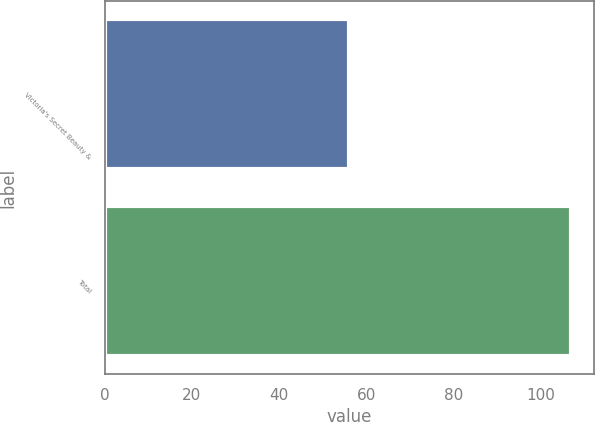Convert chart. <chart><loc_0><loc_0><loc_500><loc_500><bar_chart><fcel>Victoria's Secret Beauty &<fcel>Total<nl><fcel>56<fcel>107<nl></chart> 